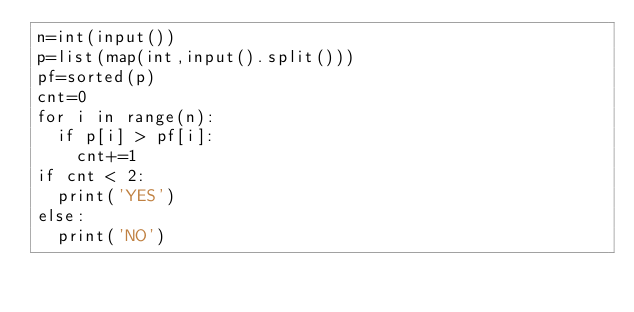<code> <loc_0><loc_0><loc_500><loc_500><_Python_>n=int(input())
p=list(map(int,input().split()))
pf=sorted(p)
cnt=0
for i in range(n):
  if p[i] > pf[i]:
    cnt+=1
if cnt < 2:
  print('YES')
else:
  print('NO')</code> 